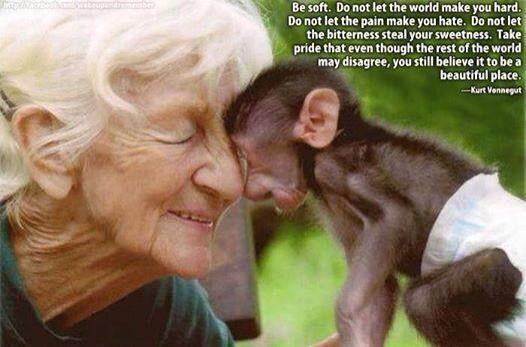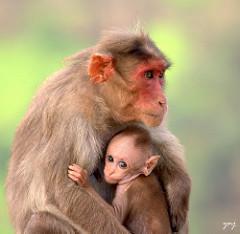The first image is the image on the left, the second image is the image on the right. For the images displayed, is the sentence "An elderly woman is touching the ape's face with her face." factually correct? Answer yes or no. Yes. The first image is the image on the left, the second image is the image on the right. Analyze the images presented: Is the assertion "An older woman is showing some affection to a monkey." valid? Answer yes or no. Yes. 